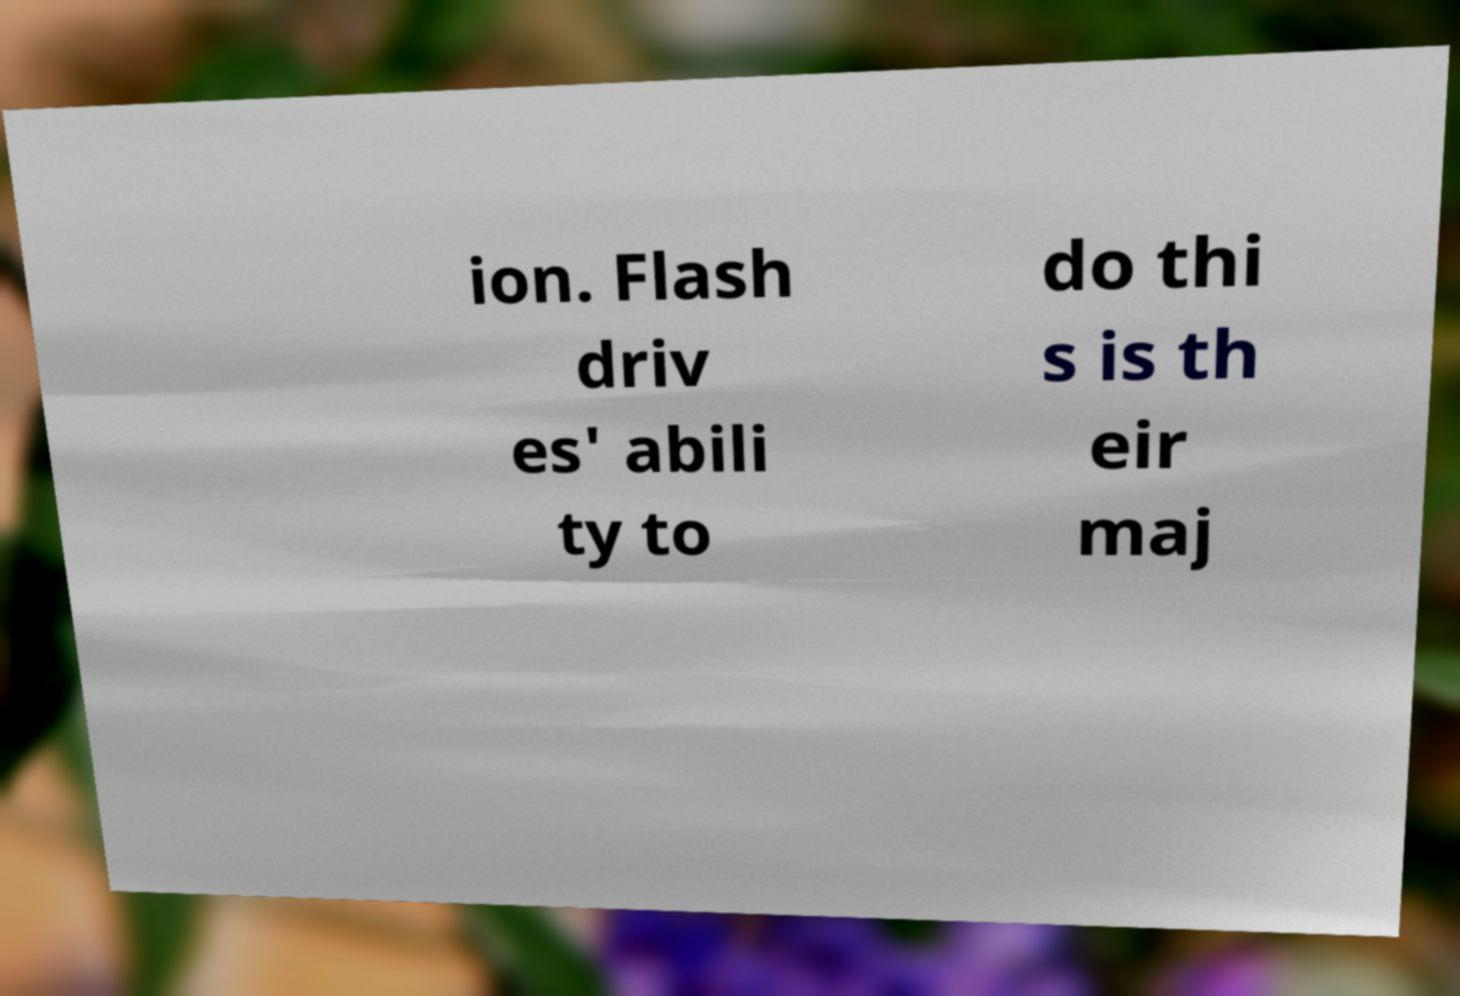There's text embedded in this image that I need extracted. Can you transcribe it verbatim? ion. Flash driv es' abili ty to do thi s is th eir maj 